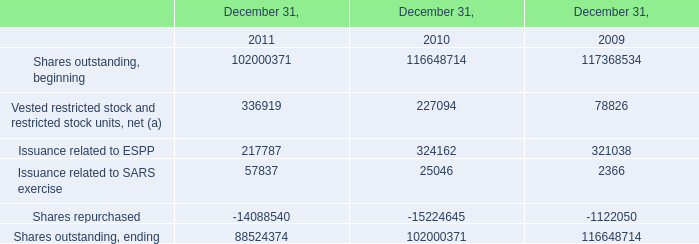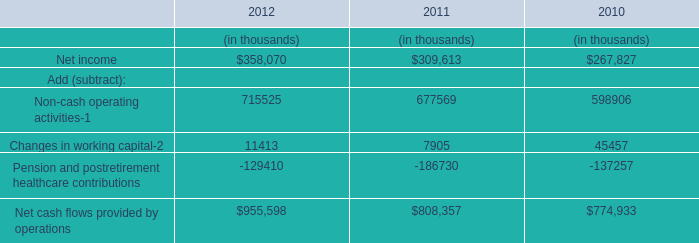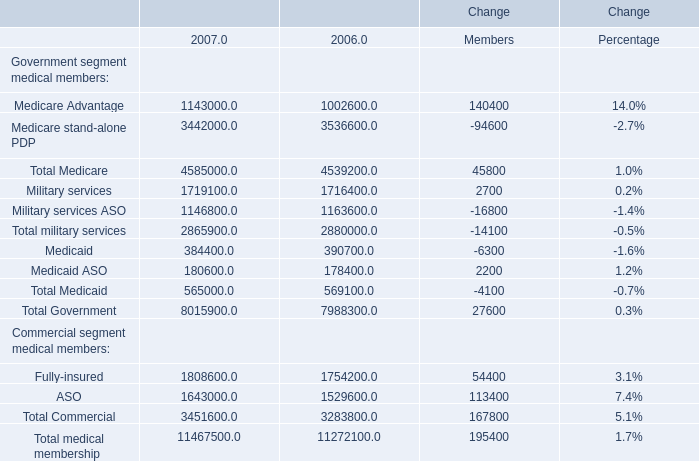What is the growing rate of Total medical membership in the year with the least amount in terms of Total Medicaid? 
Computations: ((11467500 - 11272100) / 11272100)
Answer: 0.01733. 